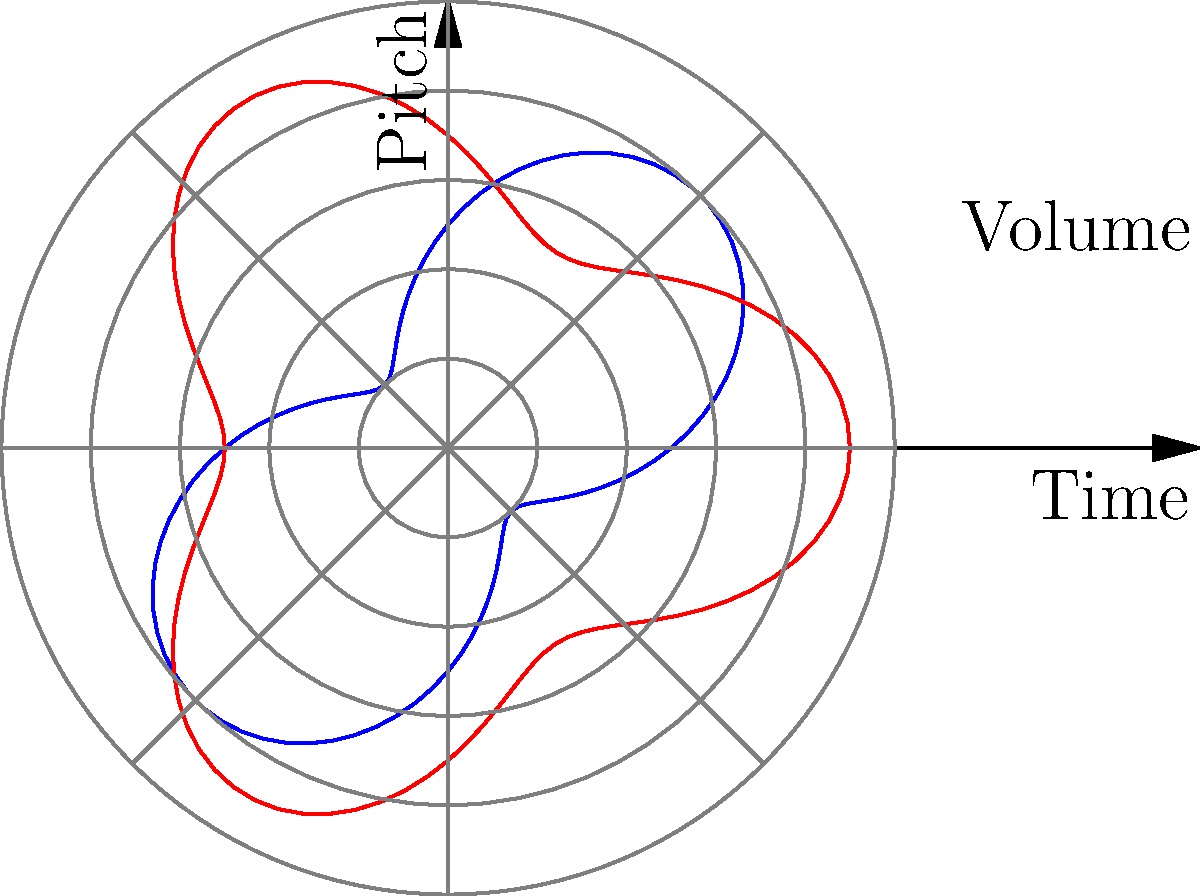In the polar graph shown, two musical elements are plotted over time. The blue curve represents pitch, while the red curve represents volume. What characteristic of the pitch (blue curve) suggests a repeating melodic pattern, and how does this relate to the volume (red curve) in terms of musical composition? To answer this question, we need to analyze the characteristics of both curves:

1. Pitch (blue curve):
   - The blue curve shows a sinusoidal pattern.
   - It completes two full cycles in the given time frame (0 to 2π).
   - This suggests a repeating melodic pattern that occurs twice in the piece.

2. Volume (red curve):
   - The red curve also shows a periodic pattern, but with a different frequency.
   - It completes three full cycles in the given time frame.

3. Relationship between pitch and volume:
   - The pitch cycle (2 repetitions) and volume cycle (3 repetitions) have different frequencies.
   - This creates a polyrhythmic effect, where the melody and dynamics interact in a complex manner.

4. Musical composition implications:
   - The repeating pitch pattern suggests a recurring melodic theme or motif.
   - The different cycle lengths of pitch and volume create tension and interest in the composition.
   - This interplay between pitch and volume can be used to create a sense of movement or development in the music.

5. Artistic interpretation:
   - As a painter inspired by audio recordings, this graph provides a visual representation of the music's structure.
   - The repeating patterns and interactions between pitch and volume could inspire visual elements in the artwork, such as recurring shapes or intertwining lines.

The characteristic of the pitch (blue curve) that suggests a repeating melodic pattern is its regular sinusoidal shape that completes two full cycles. This relates to the volume (red curve) in creating a complex rhythmic structure due to their different cycle frequencies, which can be used to create depth and interest in both the musical composition and the resulting artwork.
Answer: The pitch curve's regular sinusoidal pattern with two full cycles suggests a repeating melody, creating a polyrhythmic effect with the volume curve's three cycles, enhancing musical complexity. 